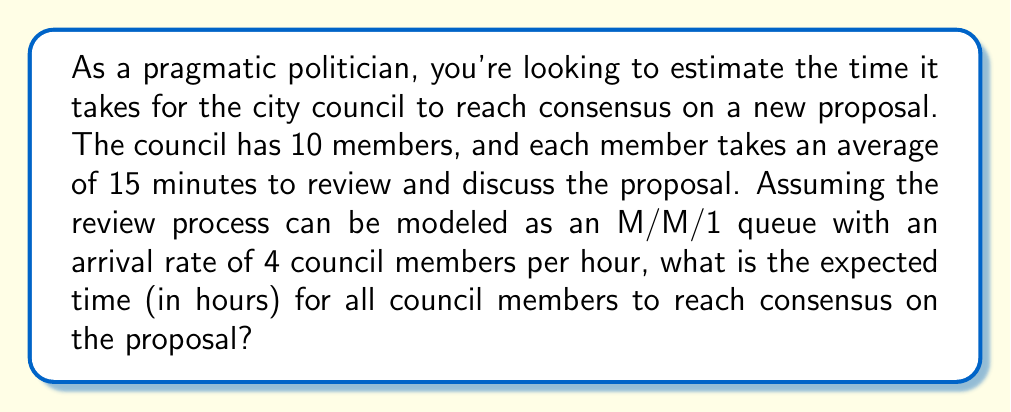Can you solve this math problem? Let's approach this step-by-step using queueing theory:

1) We have an M/M/1 queue, where:
   - $\lambda$ = arrival rate = 4 council members per hour
   - $\mu$ = service rate = 60 minutes / 15 minutes = 4 council members per hour

2) The utilization factor $\rho$ is:
   $$\rho = \frac{\lambda}{\mu} = \frac{4}{4} = 1$$

3) In an M/M/1 queue, the expected time in the system (W) is given by:
   $$W = \frac{1}{\mu - \lambda}$$

   However, this formula doesn't work when $\rho = 1$ (as in our case), because it would lead to division by zero.

4) When $\rho = 1$, we need to use a different approach. In this case, the queue behaves like a random walk, and the expected time for all N customers to be served is:
   $$E[T] = \frac{N}{\mu}$$

5) In our case, N = 10 (number of council members) and $\mu = 4$ per hour.

6) Therefore, the expected time to reach consensus is:
   $$E[T] = \frac{10}{4} = 2.5 \text{ hours}$$
Answer: 2.5 hours 